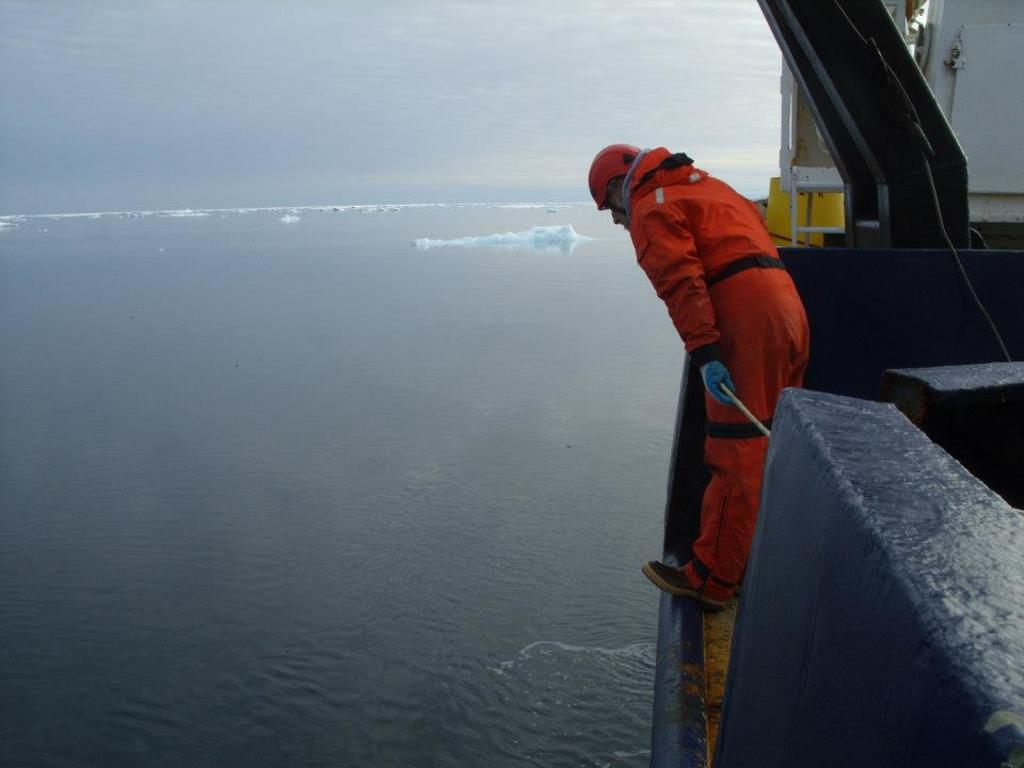What is the main subject of the image? There is a person standing in the image. What is the person wearing? The person is wearing an orange dress. What can be seen in the background of the image? There are icebergs in the background of the image. What is visible at the bottom of the image? There is water visible at the bottom of the image. What type of lock can be seen on the person's dress in the image? There is no lock present on the person's dress in the image. What kind of flame is visible near the icebergs in the image? There is no flame visible near the icebergs in the image. 